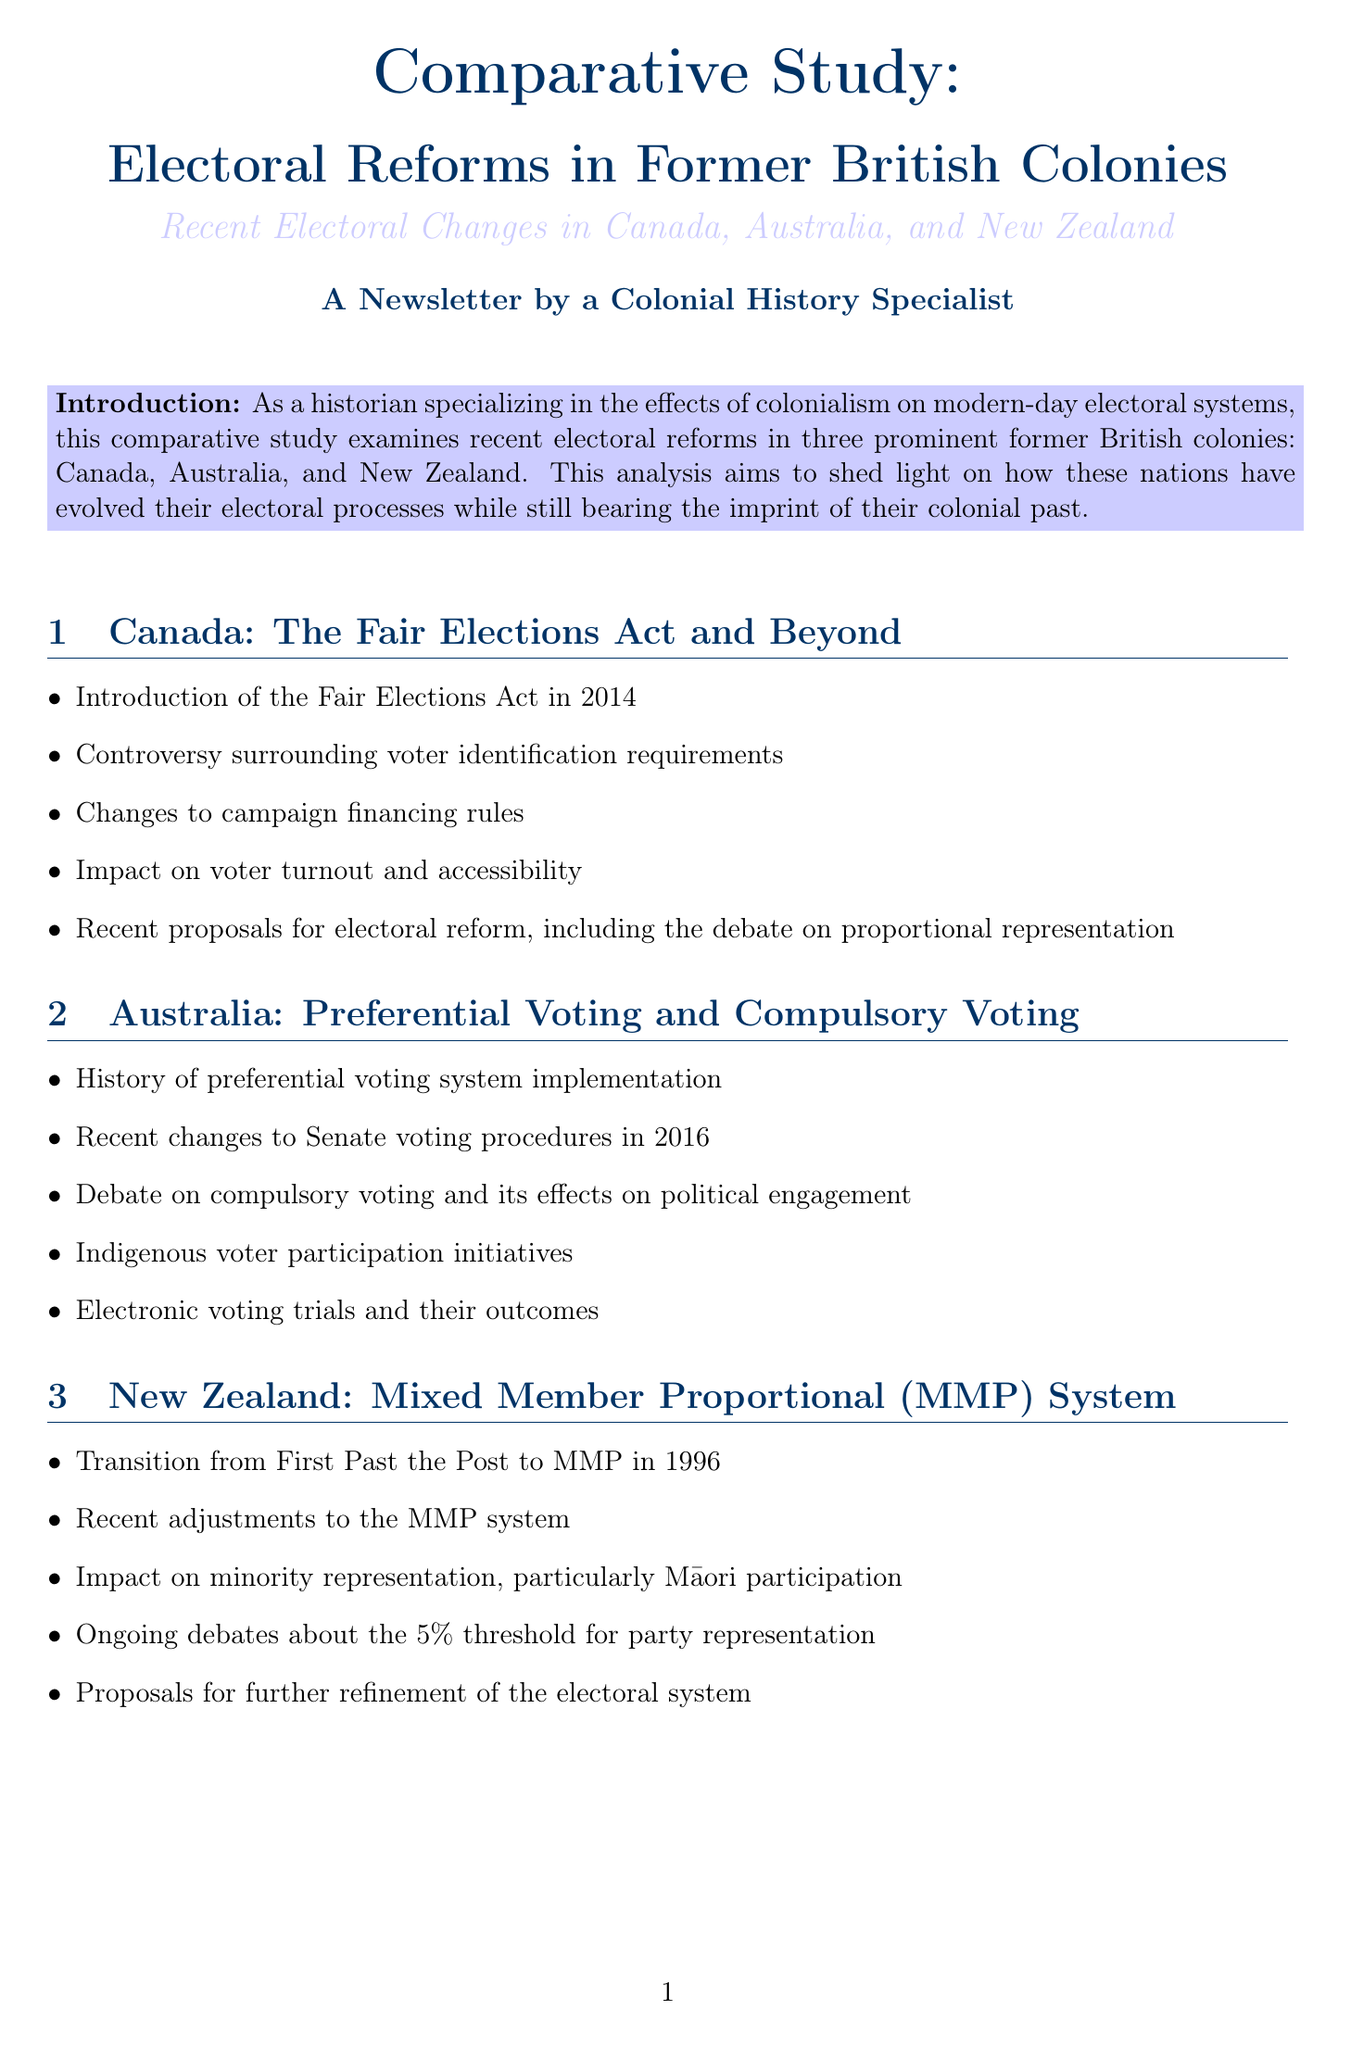What electoral act was introduced in Canada in 2014? The Fair Elections Act was introduced in Canada in 2014.
Answer: The Fair Elections Act What voting system did New Zealand transition to in 1996? New Zealand transitioned from First Past the Post to the Mixed Member Proportional (MMP) system in 1996.
Answer: Mixed Member Proportional (MMP) system What is examined in the comparative analysis section? The comparative analysis section examines colonial legacies, voter participation rates, and more across the countries.
Answer: Colonial legacies, voter participation rates, and more Which country saw recent changes to Senate voting procedures in 2016? Australia saw recent changes to Senate voting procedures in 2016.
Answer: Australia What percentage of indigenous MPs is shown in the Indigenous Representation in Parliament chart? The chart shows the percentage of indigenous MPs in each country's legislature over the last three election cycles.
Answer: Percentage of indigenous MPs What initiative is highlighted in Australia's voter demographics? Indigenous voter participation initiatives are highlighted in Australia's voter demographics.
Answer: Indigenous voter participation initiatives What is the topic of the pie charts in the document? The pie charts illustrate public opinion on proposed electoral reforms in each country.
Answer: Public opinion on proposed electoral reforms What is a significant aspect of New Zealand's recent electoral changes? Significant aspects include adjustments to the MMP system and ongoing debates about the 5% threshold for party representation.
Answer: Adjustments to the MMP system What demographic factor is considered in Canada's voter demographic section? The age distribution of voters in the 2019 federal election is considered in Canada's voter demographic section.
Answer: Age distribution of voters 